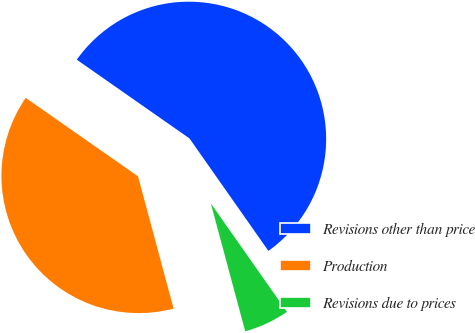<chart> <loc_0><loc_0><loc_500><loc_500><pie_chart><fcel>Revisions other than price<fcel>Production<fcel>Revisions due to prices<nl><fcel>55.56%<fcel>38.89%<fcel>5.56%<nl></chart> 